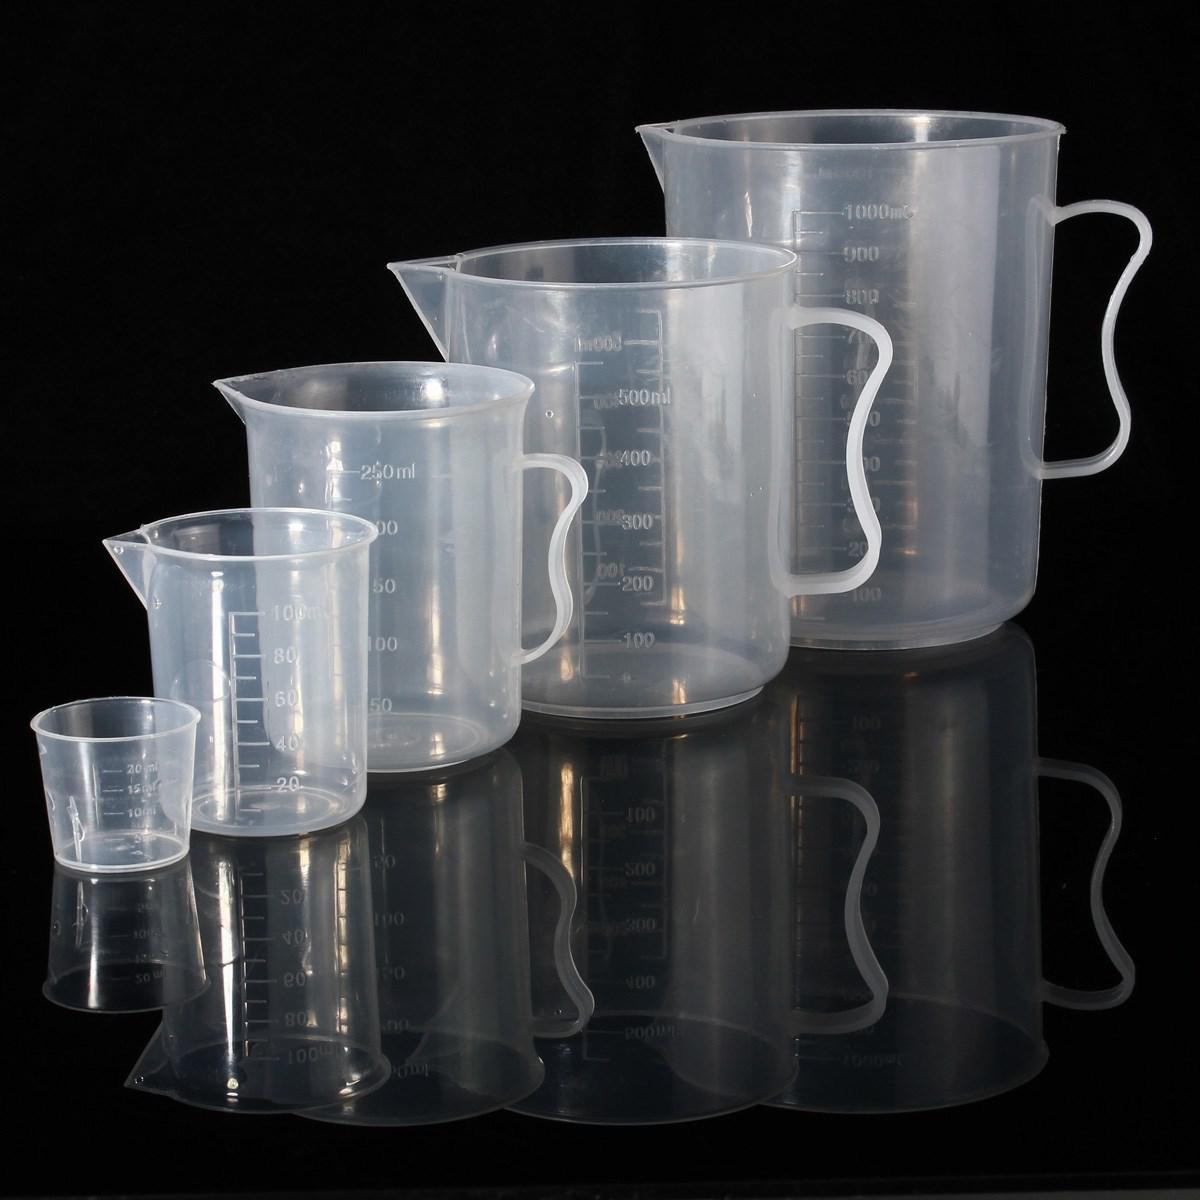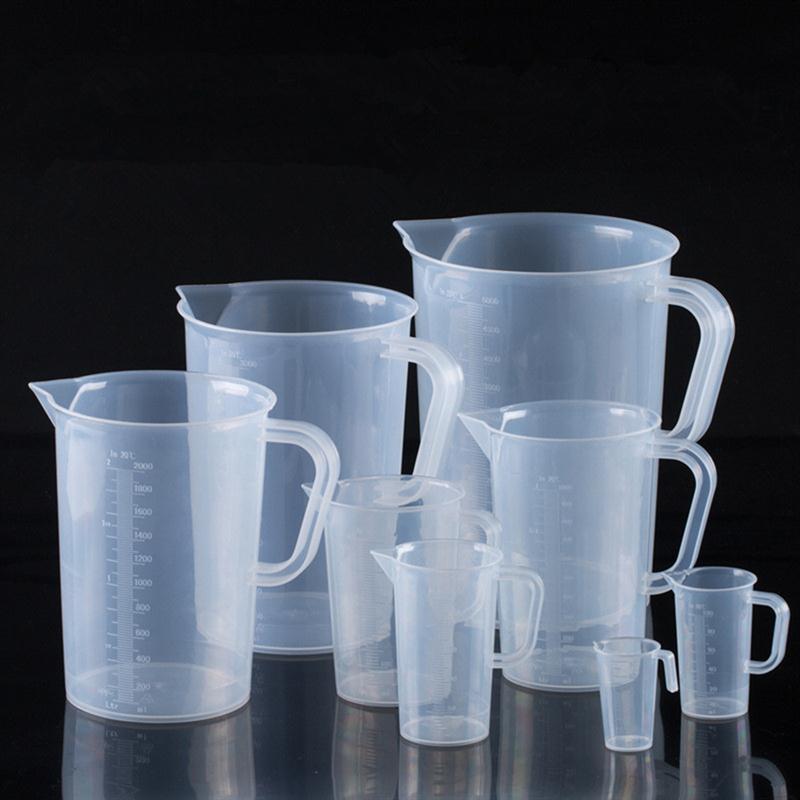The first image is the image on the left, the second image is the image on the right. Assess this claim about the two images: "One of the images contains exactly five measuring cups.". Correct or not? Answer yes or no. Yes. 